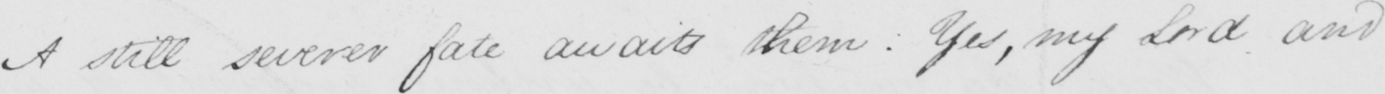Please transcribe the handwritten text in this image. A still severer fate awaits them :  Yes , my Lord and 